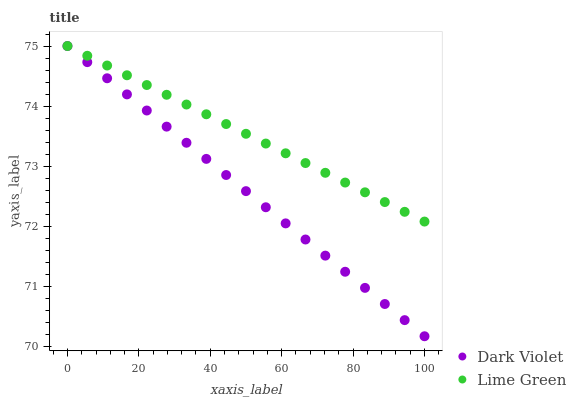Does Dark Violet have the minimum area under the curve?
Answer yes or no. Yes. Does Lime Green have the maximum area under the curve?
Answer yes or no. Yes. Does Dark Violet have the maximum area under the curve?
Answer yes or no. No. Is Dark Violet the smoothest?
Answer yes or no. Yes. Is Lime Green the roughest?
Answer yes or no. Yes. Is Dark Violet the roughest?
Answer yes or no. No. Does Dark Violet have the lowest value?
Answer yes or no. Yes. Does Dark Violet have the highest value?
Answer yes or no. Yes. Does Dark Violet intersect Lime Green?
Answer yes or no. Yes. Is Dark Violet less than Lime Green?
Answer yes or no. No. Is Dark Violet greater than Lime Green?
Answer yes or no. No. 